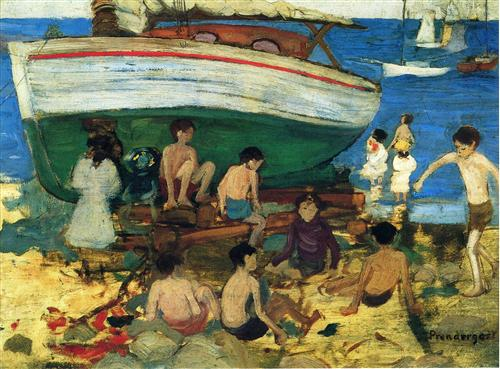How do the people in the image seem to interact with their environment? The individuals in the painting interact with their sandy surroundings in a relaxed and unhurried manner. Several adults and children are directly engaging with the environment: some sit on the beach, basking in the sunshine and shadows cast by the boat, while others stroll or play near the water's edge. Their interactions suggest a harmonious blend of human activity and natural beauty, characteristic of a peaceful, leisurely day at the beach. 